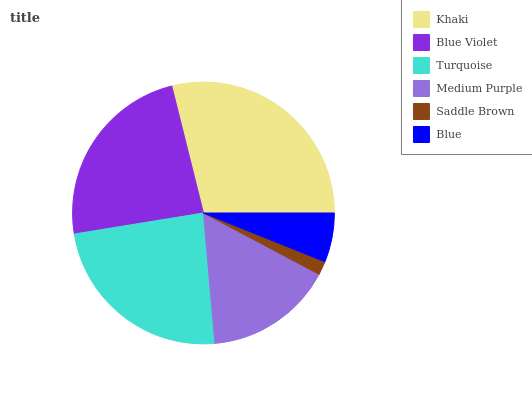Is Saddle Brown the minimum?
Answer yes or no. Yes. Is Khaki the maximum?
Answer yes or no. Yes. Is Blue Violet the minimum?
Answer yes or no. No. Is Blue Violet the maximum?
Answer yes or no. No. Is Khaki greater than Blue Violet?
Answer yes or no. Yes. Is Blue Violet less than Khaki?
Answer yes or no. Yes. Is Blue Violet greater than Khaki?
Answer yes or no. No. Is Khaki less than Blue Violet?
Answer yes or no. No. Is Blue Violet the high median?
Answer yes or no. Yes. Is Medium Purple the low median?
Answer yes or no. Yes. Is Blue the high median?
Answer yes or no. No. Is Blue Violet the low median?
Answer yes or no. No. 